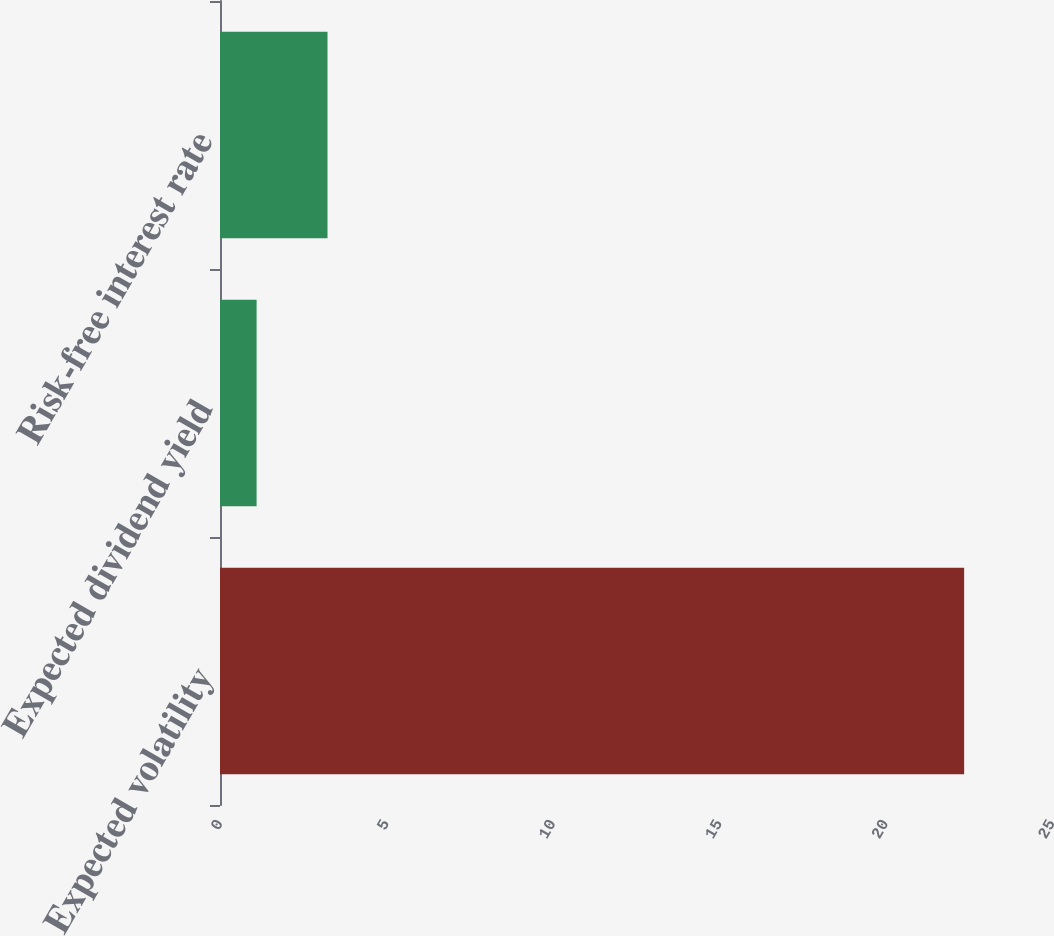<chart> <loc_0><loc_0><loc_500><loc_500><bar_chart><fcel>Expected volatility<fcel>Expected dividend yield<fcel>Risk-free interest rate<nl><fcel>22.36<fcel>1.1<fcel>3.23<nl></chart> 